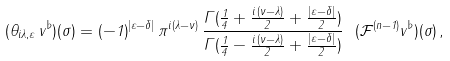<formula> <loc_0><loc_0><loc_500><loc_500>( \theta _ { i \lambda , \varepsilon } \, v ^ { \flat } ) ( \sigma ) = ( - 1 ) ^ { | \varepsilon - \delta | } \, \pi ^ { i ( \lambda - \nu ) } \, \frac { \Gamma ( \frac { 1 } { 4 } + \frac { i \, ( \nu - \lambda ) } { 2 } + \frac { | \varepsilon - \delta | } { 2 } ) } { \Gamma ( \frac { 1 } { 4 } - \frac { i \, ( \nu - \lambda ) } { 2 } + \frac { | \varepsilon - \delta | } { 2 } ) } \ ( { \mathcal { F } } ^ { ( n - 1 ) } v ^ { \flat } ) ( \sigma ) \, ,</formula> 